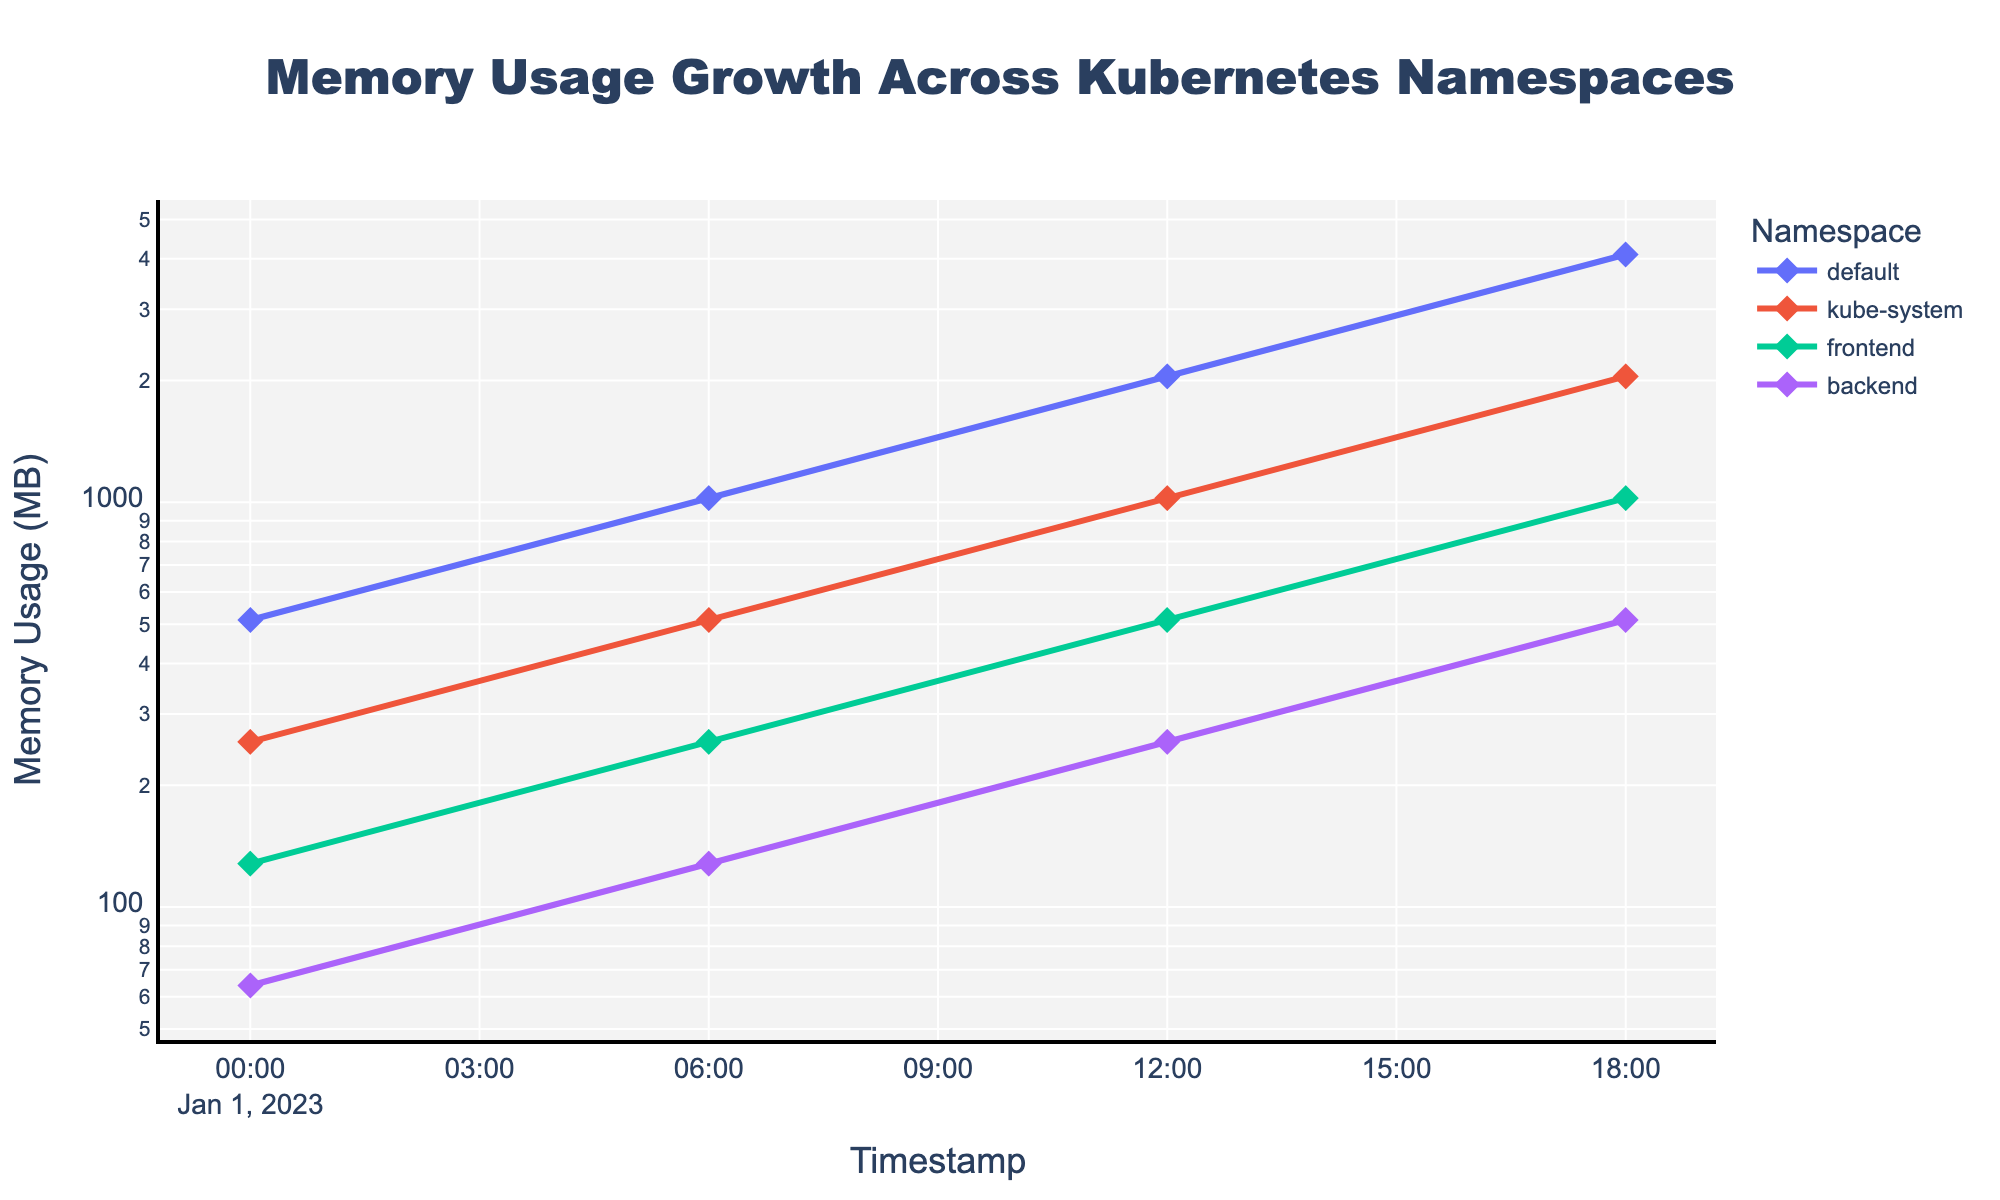What's the title of the plot? The title of the plot is displayed at the top in a larger font size, indicating the main theme of the graph.
Answer: Memory Usage Growth Across Kubernetes Namespaces What's the y-axis label? The y-axis label indicates what is being measured on the vertical axis and can be found on the left side of the plot.
Answer: Memory Usage (MB) At which timestamp does the 'default' namespace start with the memory usage of 1024 MB? We can locate the 'default' namespace on the plot and check the timestamp on the x-axis where it reaches 1024 MB.
Answer: 2023-01-01T06:00:00Z How many namespaces are plotted? Each namespace is represented by a distinct line in the plot, which we can count to determine the total number.
Answer: Four Which namespace shows the least memory usage growth over time? By comparing the slopes of lines for each namespace, we see that the 'backend' namespace increases the least steeply.
Answer: backend What is the difference in memory usage between 'default' and 'backend' namespaces at 2023-01-01T18:00:00Z? We identify the memory usage values for both namespaces at 2023-01-01T18:00:00Z and subtract the 'backend' value from the 'default' value.
Answer: 4096 - 512 = 3584 Which namespace had the lowest memory usage initially? By checking the y-values at the initial timestamp (2023-01-01T00:00:00Z), we identify the namespace with the smallest value.
Answer: backend Does the 'kube-system' namespace ever surpass the 'default' namespace in memory usage? By comparing their lines, the 'kube-system' line never surpasses the 'default' line throughout the plotted timeframe.
Answer: No Are all the namespaces' memory usage values at 2023-01-01T18:00:00Z multiples of 512 MB? We look at the y-values for all namespaces at 2023-01-01T18:00:00Z and check if they are all multiples of 512 MB.
Answer: Yes Which namespace has the most consistent growth rate over time? By observing the linearity of the lines on a log scale plot, we determine the namespace showing the steadiest trend.
Answer: default 